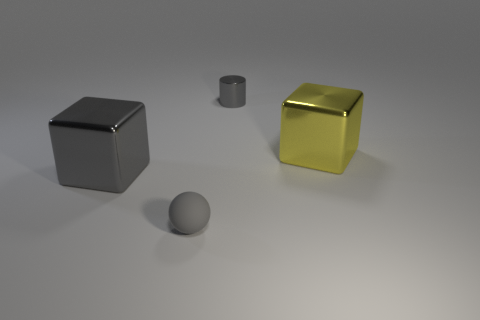There is a cylinder that is the same color as the small rubber object; what material is it?
Give a very brief answer. Metal. Is the color of the tiny metallic cylinder the same as the metallic object left of the tiny gray matte sphere?
Your answer should be very brief. Yes. Is there a large cube of the same color as the small cylinder?
Provide a short and direct response. Yes. Is the tiny metal cylinder the same color as the sphere?
Your answer should be compact. Yes. There is a small rubber object that is the same color as the metallic cylinder; what shape is it?
Your answer should be very brief. Sphere. Is there anything else that is the same color as the rubber object?
Offer a terse response. Yes. There is a block that is the same color as the tiny cylinder; what is its size?
Your answer should be compact. Large. Is the color of the small object that is in front of the yellow metal thing the same as the small metallic object?
Your answer should be compact. Yes. How many large things are in front of the gray object on the left side of the small gray sphere?
Provide a succinct answer. 0. Is the material of the block on the right side of the tiny cylinder the same as the gray sphere?
Offer a very short reply. No. 